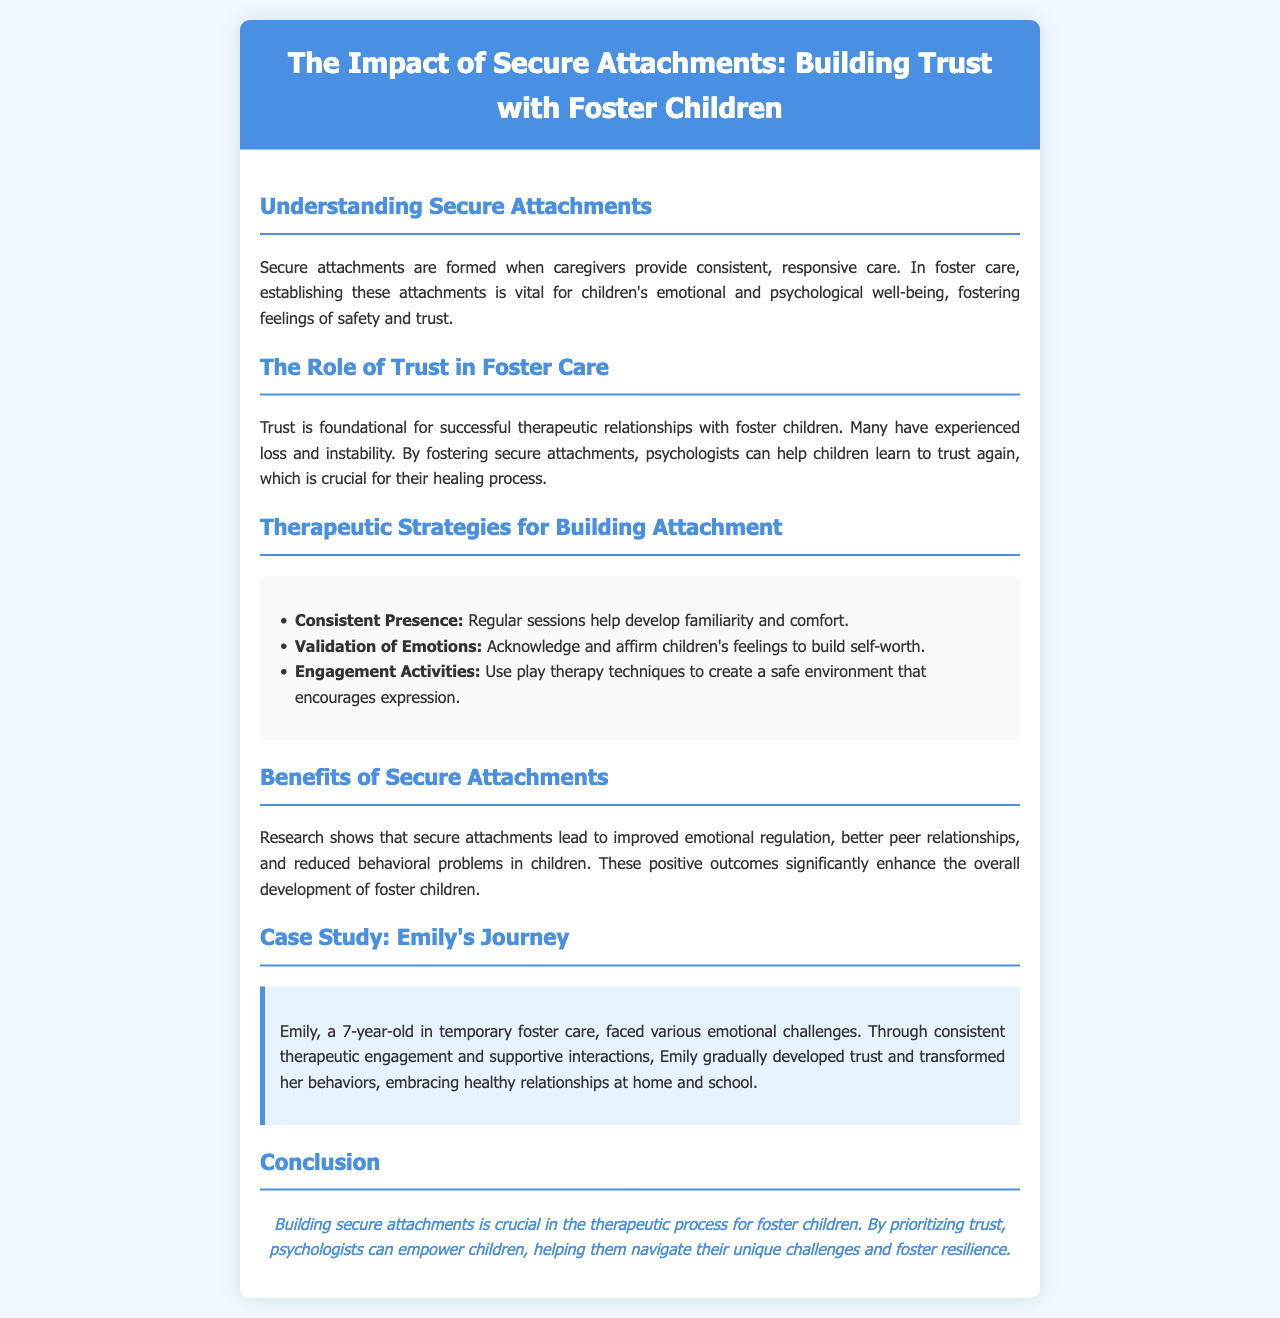What is the title of the brochure? The title is presented prominently at the top of the brochure, which is "The Impact of Secure Attachments: Building Trust with Foster Children."
Answer: The Impact of Secure Attachments: Building Trust with Foster Children What age is Emily in the case study? Emily's age is explicitly stated in the case study section of the brochure.
Answer: 7 years old What is one therapeutic strategy mentioned for building attachment? The brochure lists several strategies under the "Therapeutic Strategies for Building Attachment" section, including "Consistent Presence."
Answer: Consistent Presence What color is used for the header background? The brochure's header background color can be identified from its design elements.
Answer: #4a90e2 What is the conclusion focus according to the document? The conclusion emphasizes the importance of building secure attachments as part of the therapeutic process.
Answer: Building secure attachments is crucial What benefit do secure attachments lead to in children? The brochure discusses several benefits, and one specific outcome mentioned is "improved emotional regulation."
Answer: Improved emotional regulation What is emphasized as foundational for therapeutic relationships? The need for a particular quality is underscored in the section discussing the role of trust.
Answer: Trust How are children's feelings addressed according to therapeutic strategies? The affirmation of children's emotions is highlighted in the strategies section.
Answer: Validation of Emotions 